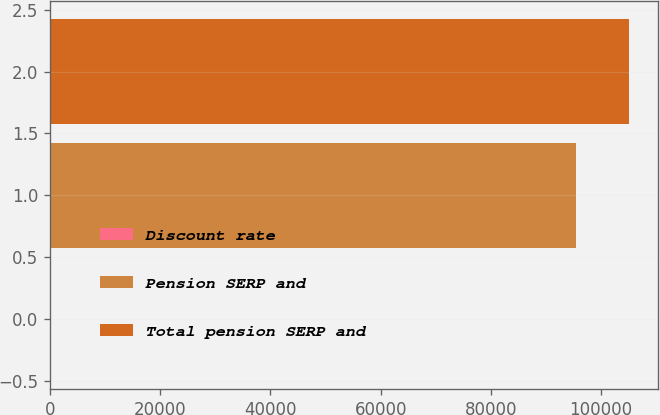<chart> <loc_0><loc_0><loc_500><loc_500><bar_chart><fcel>Discount rate<fcel>Pension SERP and<fcel>Total pension SERP and<nl><fcel>5.74<fcel>95528<fcel>105132<nl></chart> 